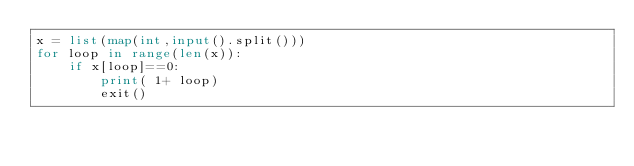Convert code to text. <code><loc_0><loc_0><loc_500><loc_500><_Python_>x = list(map(int,input().split()))
for loop in range(len(x)):
    if x[loop]==0:
        print( 1+ loop)
        exit()
</code> 